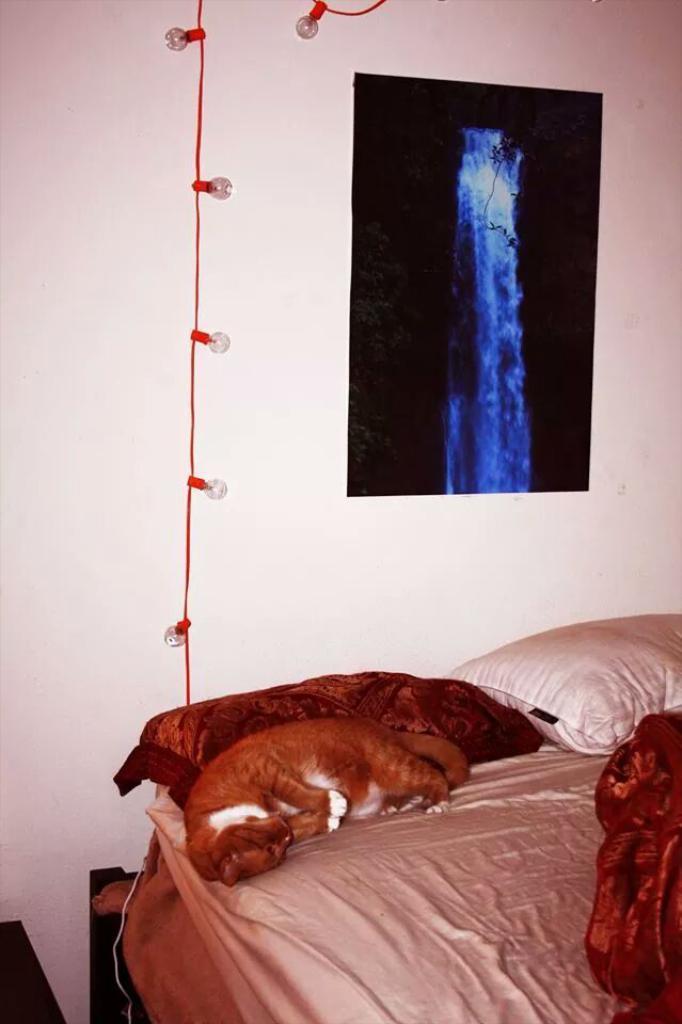How would you summarize this image in a sentence or two? There is one cat lying on the bed as we can see at the bottom of this image. There are two pillows on the right side to this cat. There is a white color wall in the background. There is one poster attached to this wall. There are some lights as we can see on the left side of this image. 